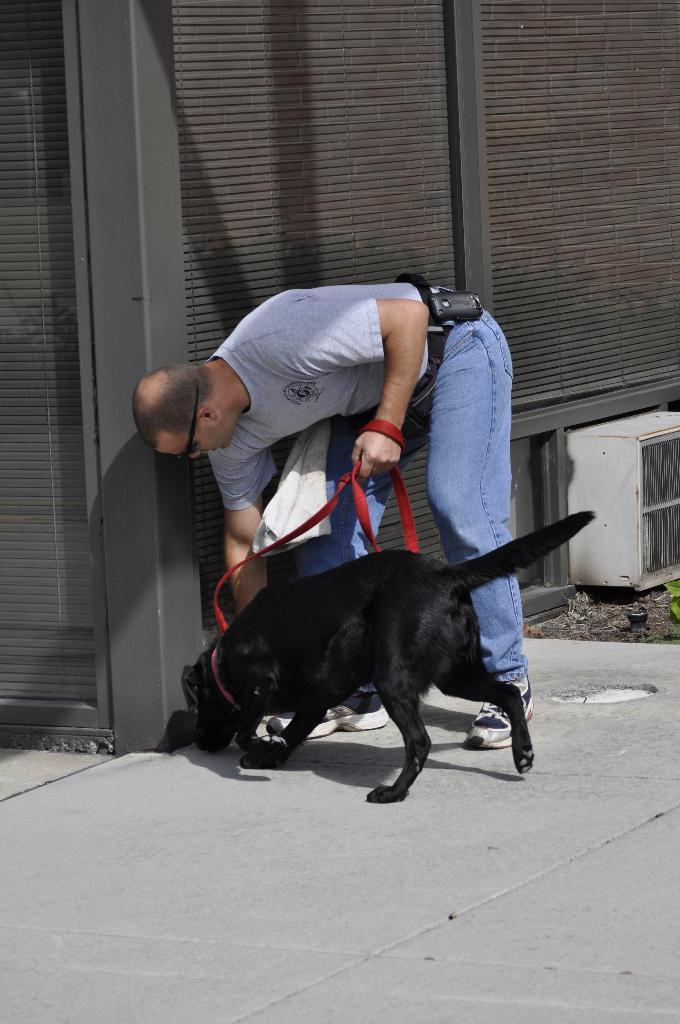Who is present in the image? There is a man in the image. What is the man doing in the image? The man is carrying a dog. What object is the man holding in his hand? The man is holding a dog belt in his hand. What type of fork can be seen in the man's hand in the image? There is no fork present in the image; the man is holding a dog belt in his hand. 